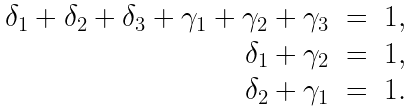Convert formula to latex. <formula><loc_0><loc_0><loc_500><loc_500>\begin{array} { r c l } \delta _ { 1 } + \delta _ { 2 } + \delta _ { 3 } + \gamma _ { 1 } + \gamma _ { 2 } + \gamma _ { 3 } & = & 1 , \\ \delta _ { 1 } + \gamma _ { 2 } & = & 1 , \\ \delta _ { 2 } + \gamma _ { 1 } & = & 1 . \end{array}</formula> 